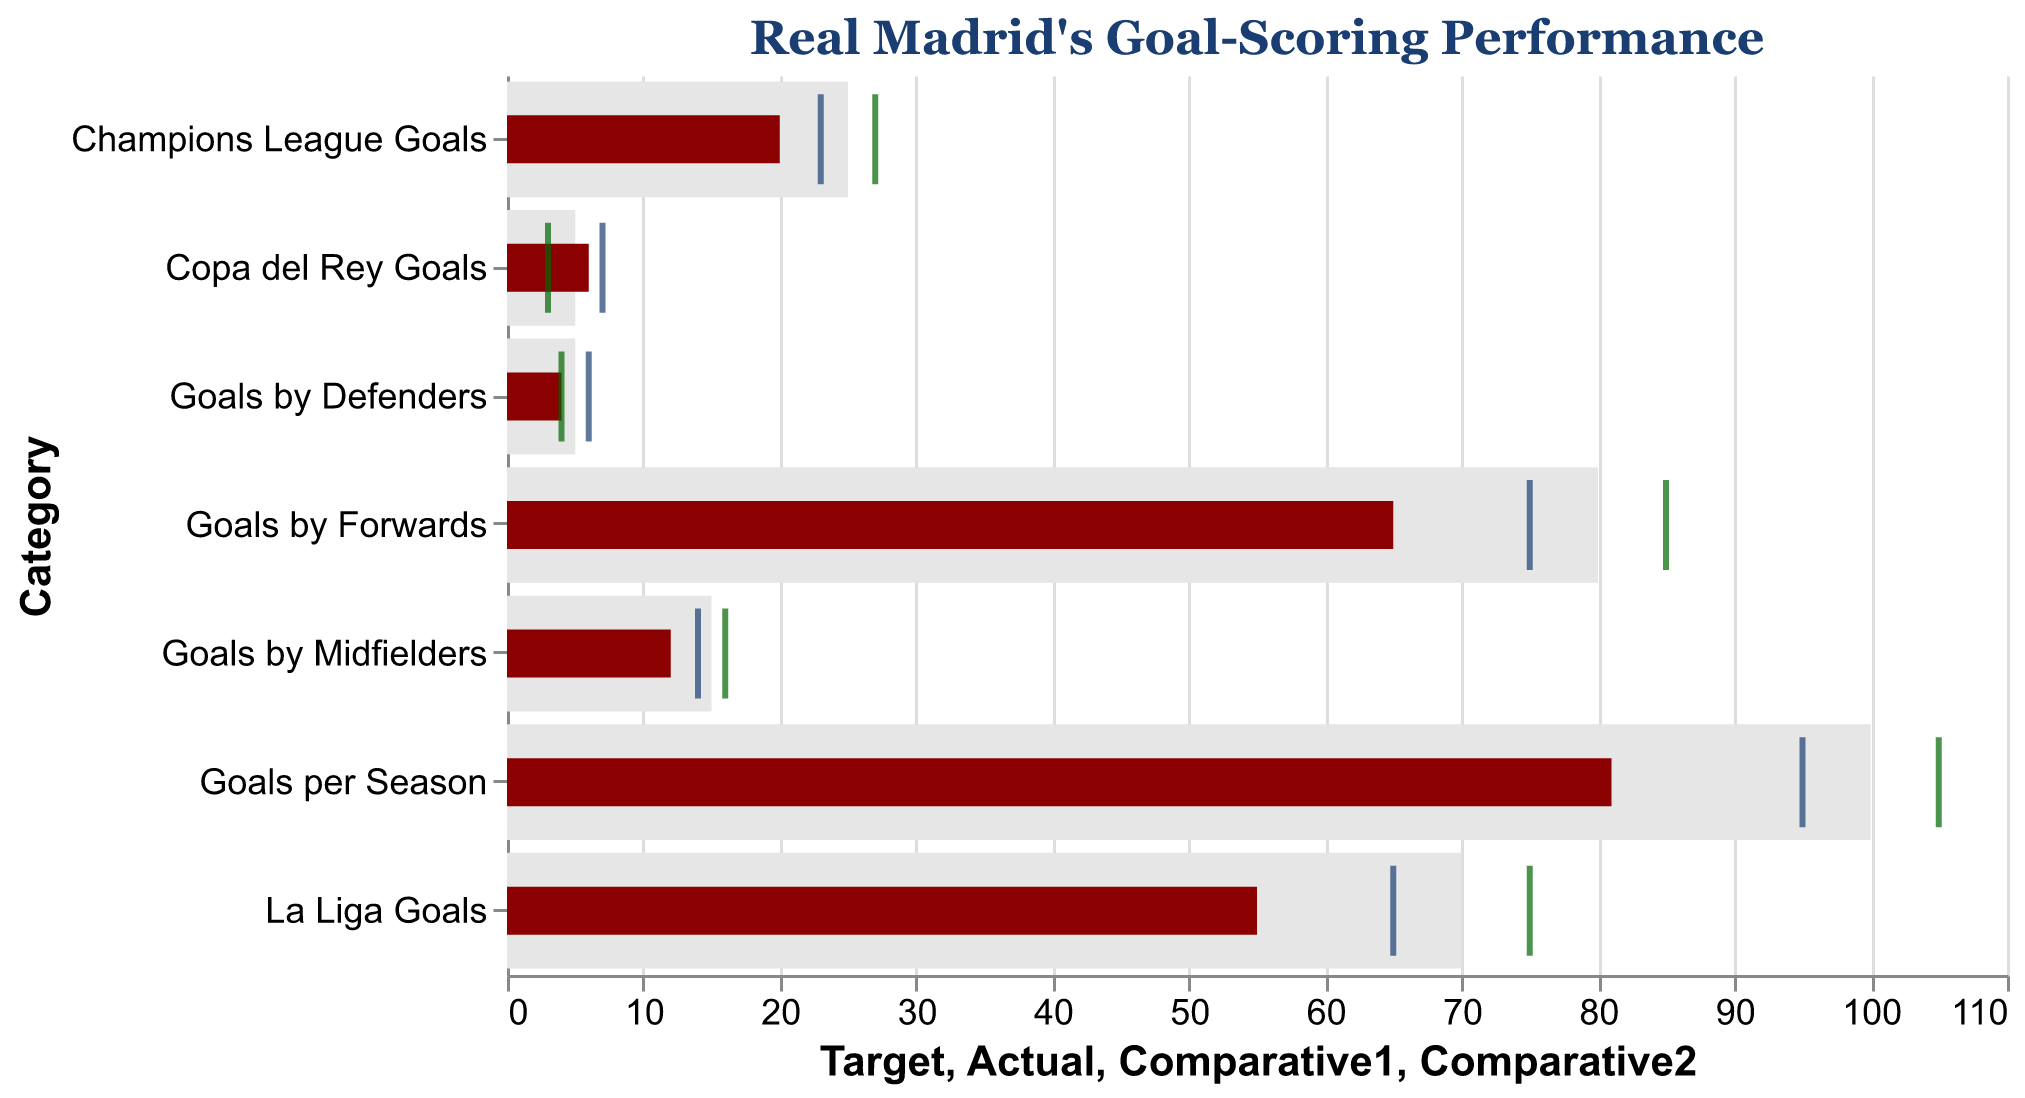Which category has the smallest gap between the Actual and Target values? The category with the smallest gap between Actual and Target values is "Copa del Rey Goals" because the Actual value is 6 and the Target is 5, resulting in a gap of only 1 goal. All other categories have larger differences.
Answer: Copa del Rey Goals What is the title of the plot? The title of the plot is positioned at the top and is very prominent. It reads: "Real Madrid's Goal-Scoring Performance".
Answer: Real Madrid's Goal-Scoring Performance How many goals are Real Madrid's defenders behind their target? Real Madrid's defenders scored 4 goals, while their target was 5. The difference is 5 - 4 = 1 goal.
Answer: 1 goal Compare the Actual goals to Comparative1 and Comparative2 for the "Goals per Season" category. Are they higher or lower? The Actual goals for "Goals per Season" are 81. Comparative1 is 95 and Comparative2 is 105. Both Comparative1 and Comparative2 are higher than the Actual goals.
Answer: Higher Which category's Actual score exceeds its target? For "Copa del Rey Goals", the Actual score (6) exceeds the target (5). All other categories have Actual scores less than their targets.
Answer: Copa del Rey Goals What colors are used to represent the Actual scores and the Comparative tick marks? The Actual scores are represented by a dark red bar, one set of Comparative tick marks is in blue, and the other set is in green.
Answer: dark red bar, blue and green ticks What is the difference between Comparative2 goals and Actual goals for the "La Liga Goals" category? For "La Liga Goals", Comparative2 goals are 75 and Actual goals are 55. The difference is 75 - 55 = 20 goals.
Answer: 20 goals How do the Actual and Comparative1 scores for "Goals by Midfielders" compare? The Actual goals by midfielders are 12, while Comparative1 is 14. Comparative1 goals are higher than Actual goals.
Answer: Comparative1 is higher What is the maximum target value across all categories? The maximum target value across all categories, which can be found by scanning through the target values, is 100 goals for the "Goals per Season" category.
Answer: 100 goals Are there any categories where the Comparative2 value is equal to the Actual value? By comparing the Actual and Comparative2 values for each category, we see that "Goals by Defenders" has an Actual value of 4 and a Comparative2 value of 4, making them equal.
Answer: Goals by Defenders 